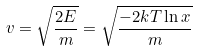Convert formula to latex. <formula><loc_0><loc_0><loc_500><loc_500>v = \sqrt { \frac { 2 E } { m } } = \sqrt { \frac { - 2 k T \ln x } { m } }</formula> 